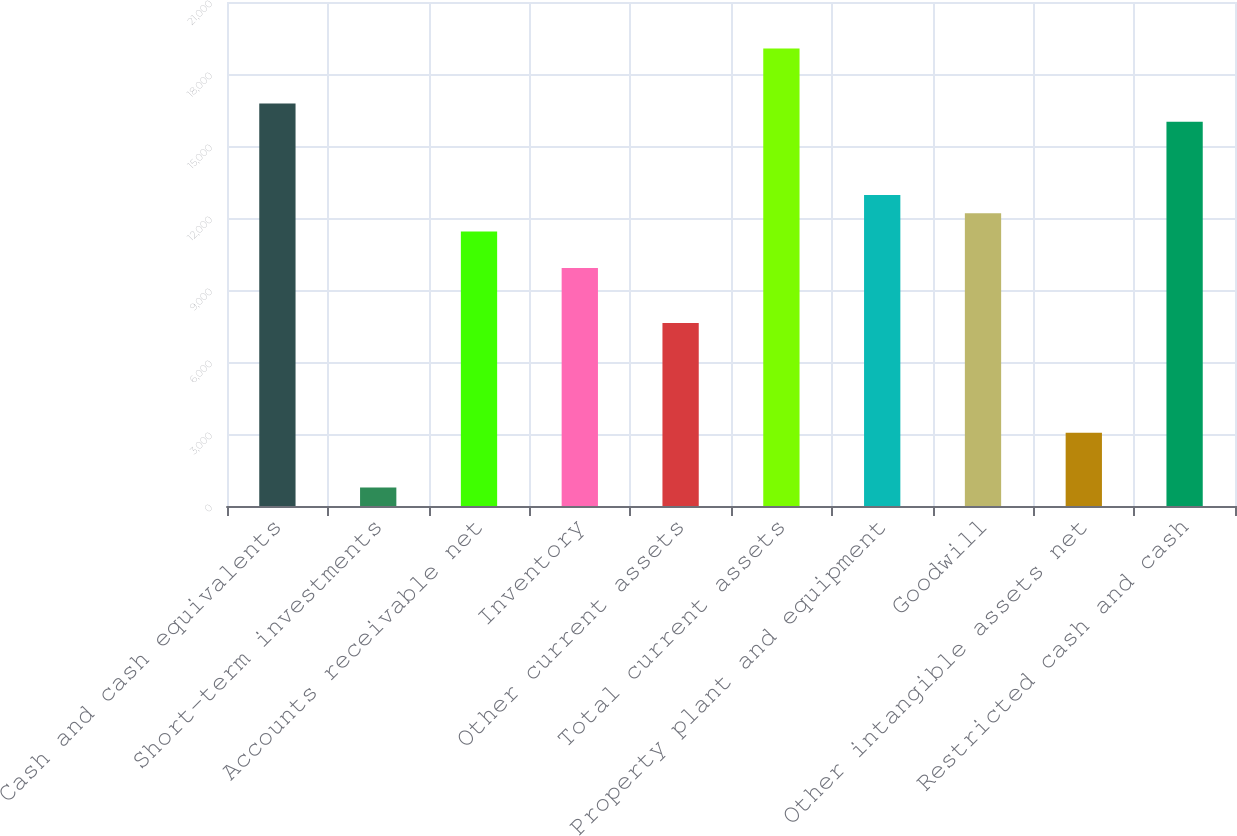<chart> <loc_0><loc_0><loc_500><loc_500><bar_chart><fcel>Cash and cash equivalents<fcel>Short-term investments<fcel>Accounts receivable net<fcel>Inventory<fcel>Other current assets<fcel>Total current assets<fcel>Property plant and equipment<fcel>Goodwill<fcel>Other intangible assets net<fcel>Restricted cash and cash<nl><fcel>16772.2<fcel>768.1<fcel>11437.5<fcel>9913.3<fcel>7627<fcel>19058.5<fcel>12961.7<fcel>12199.6<fcel>3054.4<fcel>16010.1<nl></chart> 